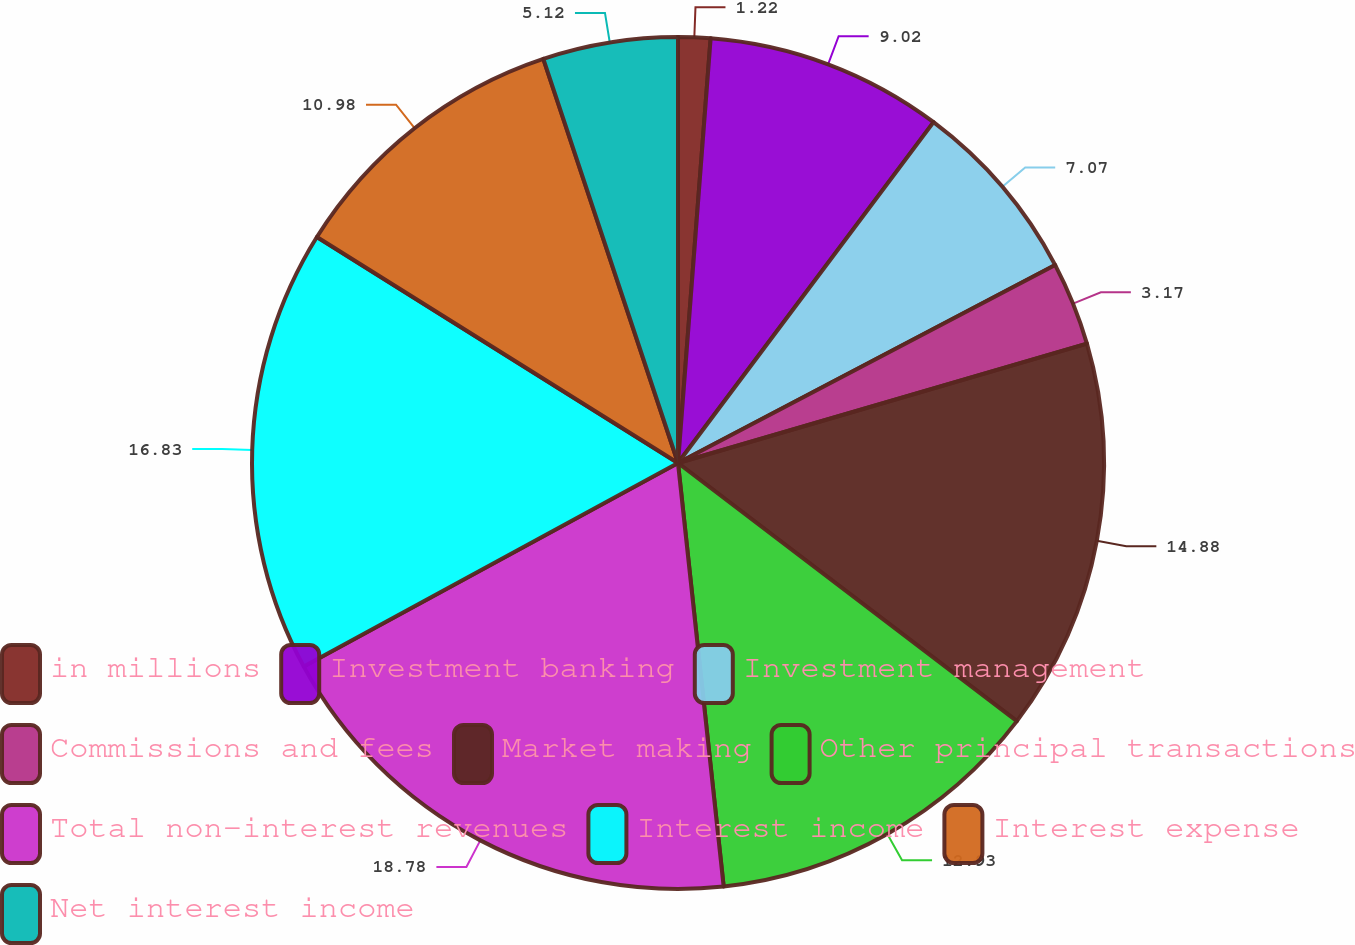Convert chart. <chart><loc_0><loc_0><loc_500><loc_500><pie_chart><fcel>in millions<fcel>Investment banking<fcel>Investment management<fcel>Commissions and fees<fcel>Market making<fcel>Other principal transactions<fcel>Total non-interest revenues<fcel>Interest income<fcel>Interest expense<fcel>Net interest income<nl><fcel>1.22%<fcel>9.02%<fcel>7.07%<fcel>3.17%<fcel>14.88%<fcel>12.93%<fcel>18.78%<fcel>16.83%<fcel>10.98%<fcel>5.12%<nl></chart> 